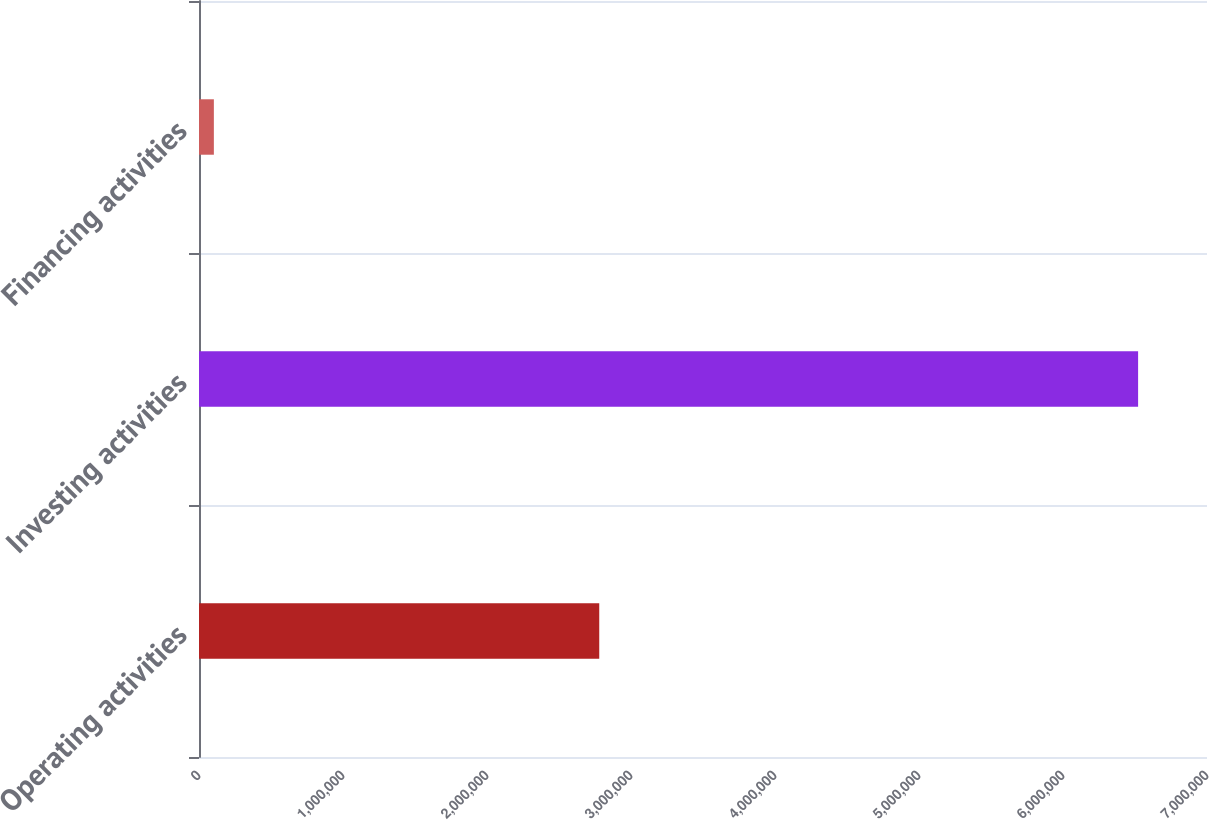Convert chart to OTSL. <chart><loc_0><loc_0><loc_500><loc_500><bar_chart><fcel>Operating activities<fcel>Investing activities<fcel>Financing activities<nl><fcel>2.77951e+06<fcel>6.52155e+06<fcel>103237<nl></chart> 